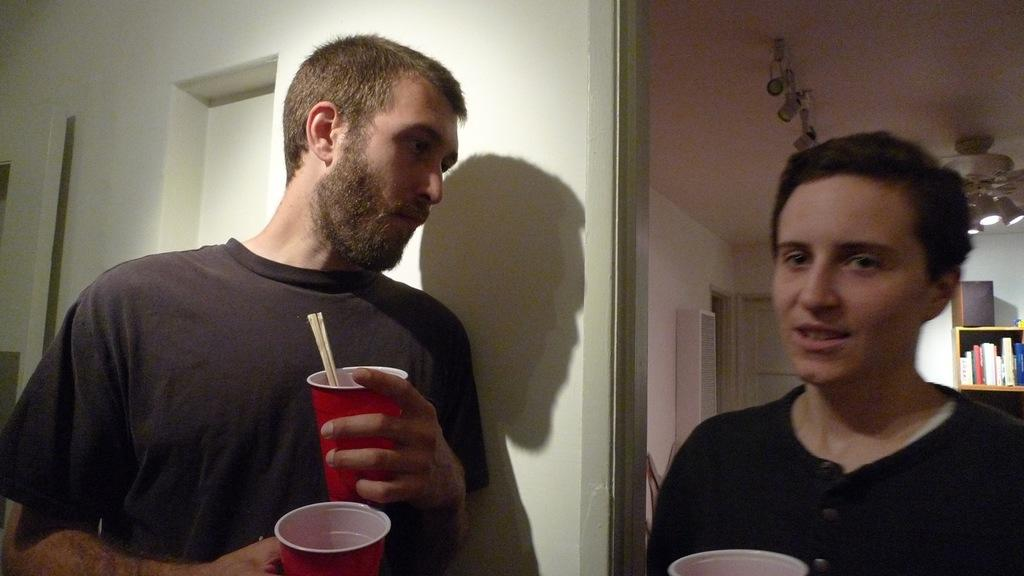How many people are in the image? There are two people in the image. What is one person holding? One person is holding glasses. What can be seen in the background of the image? There is a wall and lights in the background of the image. Where are the books located in the image? The books are in a rack on the right side of the image. Is there any quicksand visible in the image? No, there is no quicksand present in the image. Can you tell me how many times the person stretches in the image? There is no indication of anyone stretching in the image. 